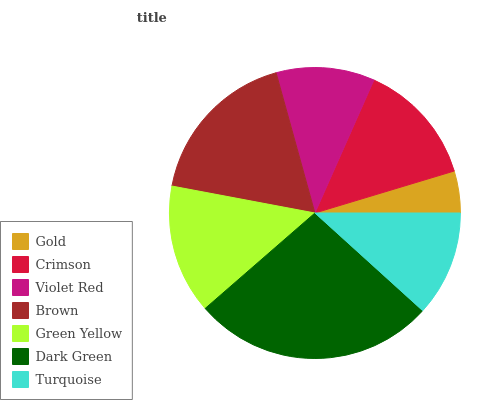Is Gold the minimum?
Answer yes or no. Yes. Is Dark Green the maximum?
Answer yes or no. Yes. Is Crimson the minimum?
Answer yes or no. No. Is Crimson the maximum?
Answer yes or no. No. Is Crimson greater than Gold?
Answer yes or no. Yes. Is Gold less than Crimson?
Answer yes or no. Yes. Is Gold greater than Crimson?
Answer yes or no. No. Is Crimson less than Gold?
Answer yes or no. No. Is Crimson the high median?
Answer yes or no. Yes. Is Crimson the low median?
Answer yes or no. Yes. Is Brown the high median?
Answer yes or no. No. Is Violet Red the low median?
Answer yes or no. No. 